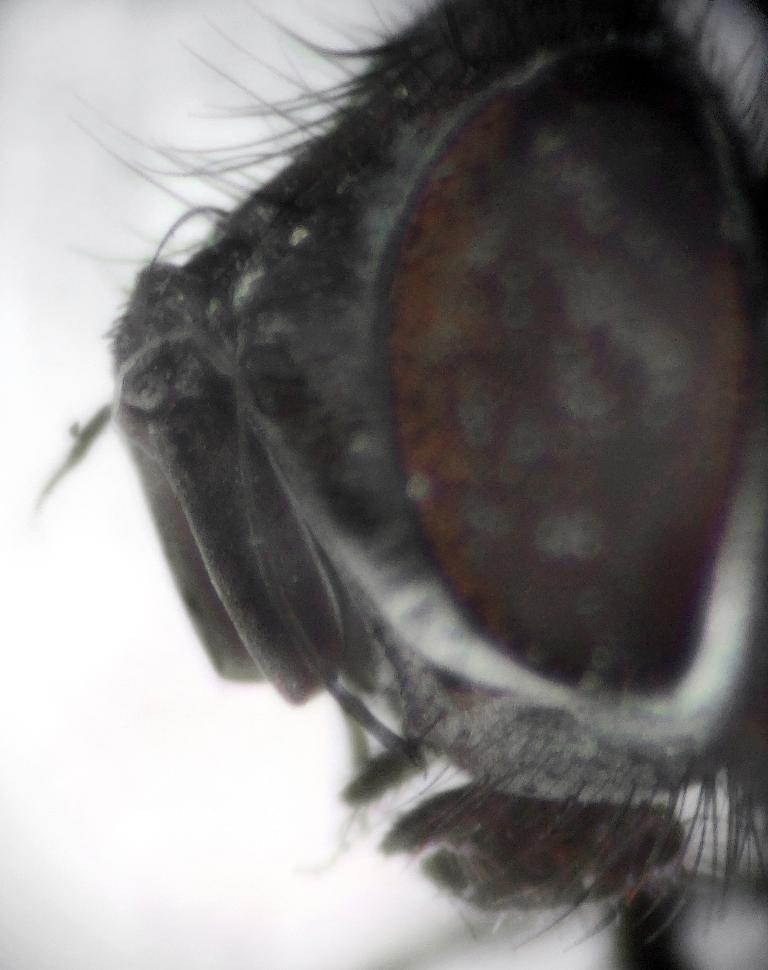What is present on the left side of the image? There is a fly on the left side of the image. What is the color scheme of the image? The image is black and white. What type of alley can be seen in the image? There is no alley present in the image; it features a fly in a black and white setting. What form does the fly take in the image? The fly is depicted in its natural form in the image. 